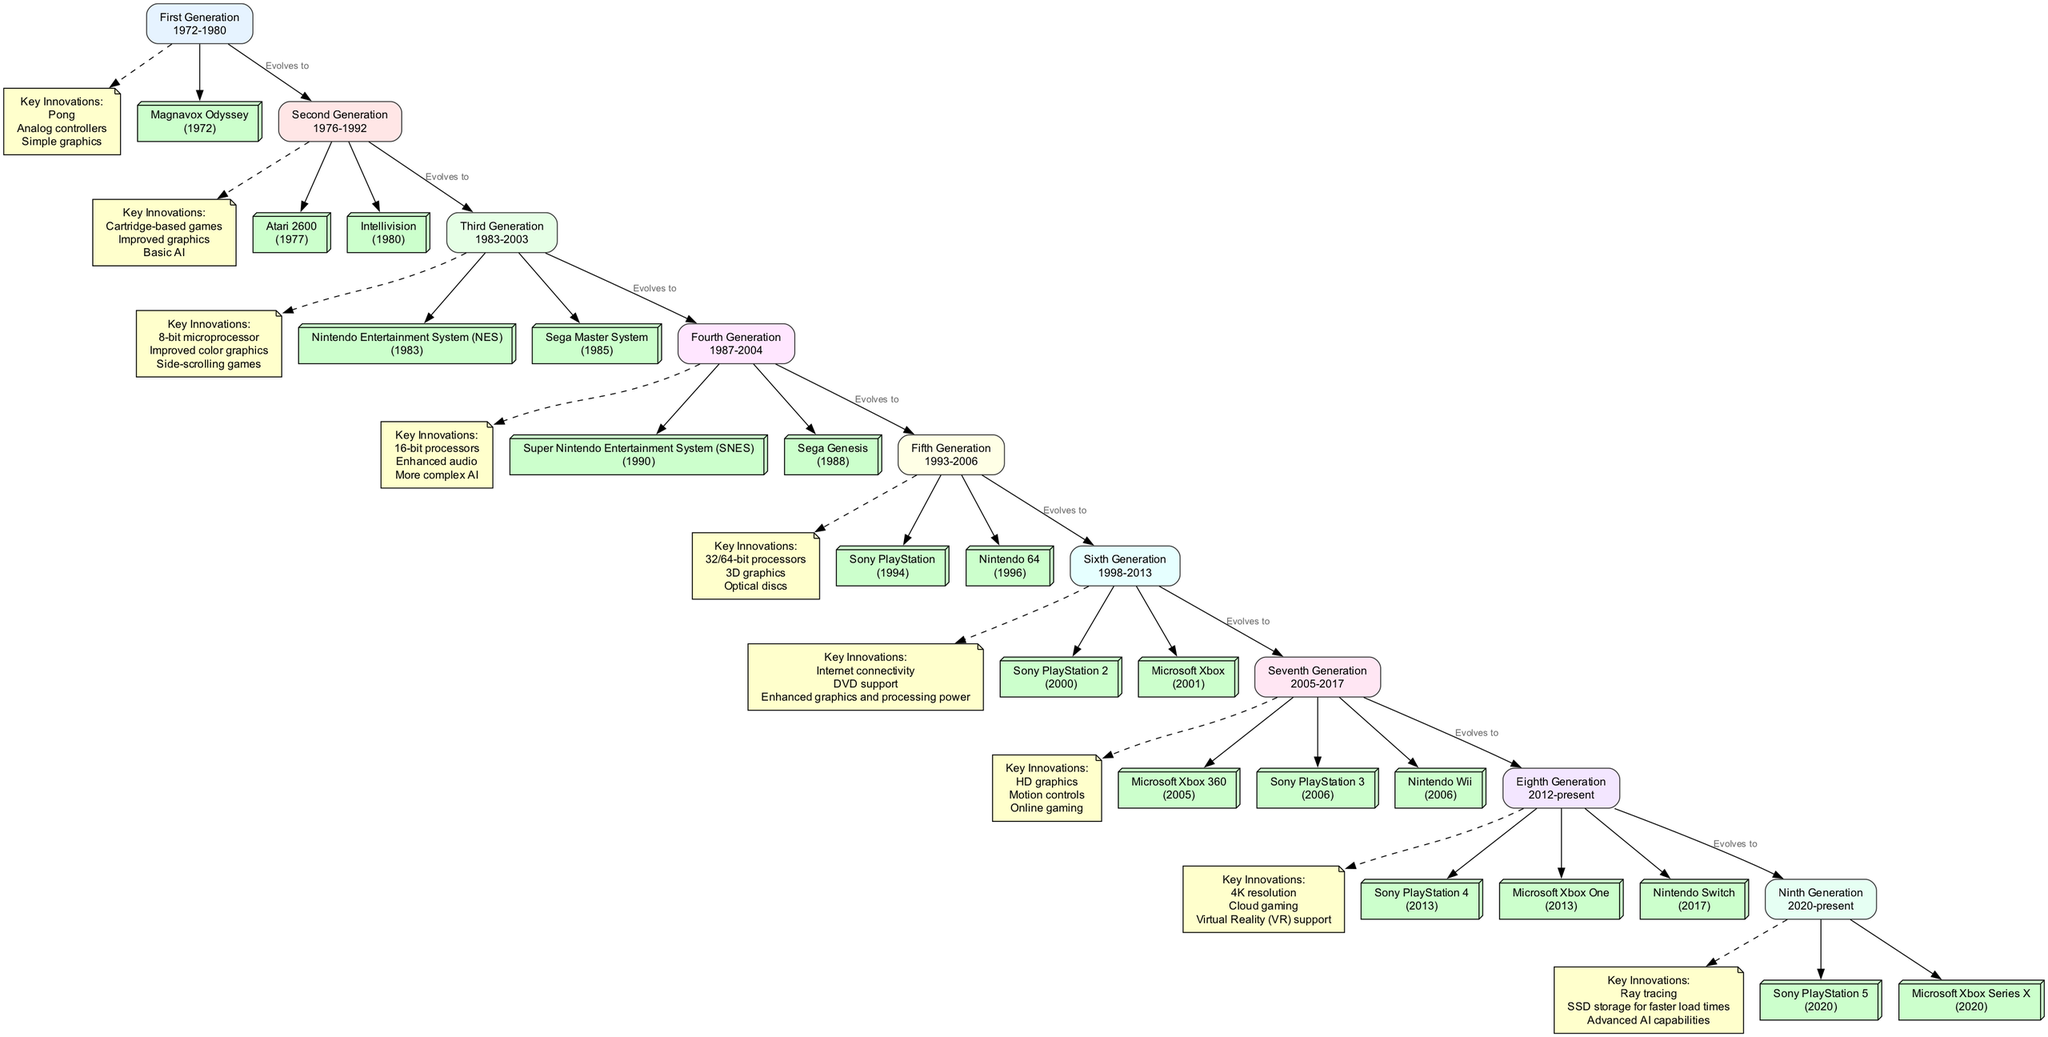What is the period of the Third Generation? The diagram shows the Third Generation as having the period defined as "1983-2003". This is indicated in the box that represents the Third Generation.
Answer: 1983-2003 How many notable consoles are listed under the Sixth Generation? By examining the Sixth Generation section, it lists two notable consoles: Sony PlayStation 2 and Microsoft Xbox. These are connected to the Sixth Generation node.
Answer: 2 Which generation introduced cloud gaming? Looking at the Eighth Generation, it states that one of its key innovations is cloud gaming. This connects the innovation to the corresponding generation node.
Answer: Eighth Generation What key innovation is associated with the Ninth Generation? The Ninth Generation in the diagram lists "Ray tracing" as one of its key innovations. This connects the innovation directly to the generation node.
Answer: Ray tracing What console was released first in the Fifth Generation? Reviewing the Notable Consoles under the Fifth Generation, it shows that the Sony PlayStation was released in 1994, while the Nintendo 64 released in 1996, making PlayStation the first.
Answer: Sony PlayStation What connects the Fourth Generation to the Fifth Generation? The diagram illustrates a direct edge with the label "Evolves to" from the Fourth Generation to the Fifth Generation, indicating a developmental transition between these two generations.
Answer: Evolves to What is a major innovation introduced in the Seventh Generation? The diagram outlines "HD graphics" as a major innovation unique to the Seventh Generation, as indicated in the key innovations section of that generation.
Answer: HD graphics How many generations have the innovation of optical discs? By reviewing the diagram, the only generation that mentions "Optical discs" as a key innovation is the Fifth Generation. Therefore, this innovation appears only in one generation.
Answer: 1 